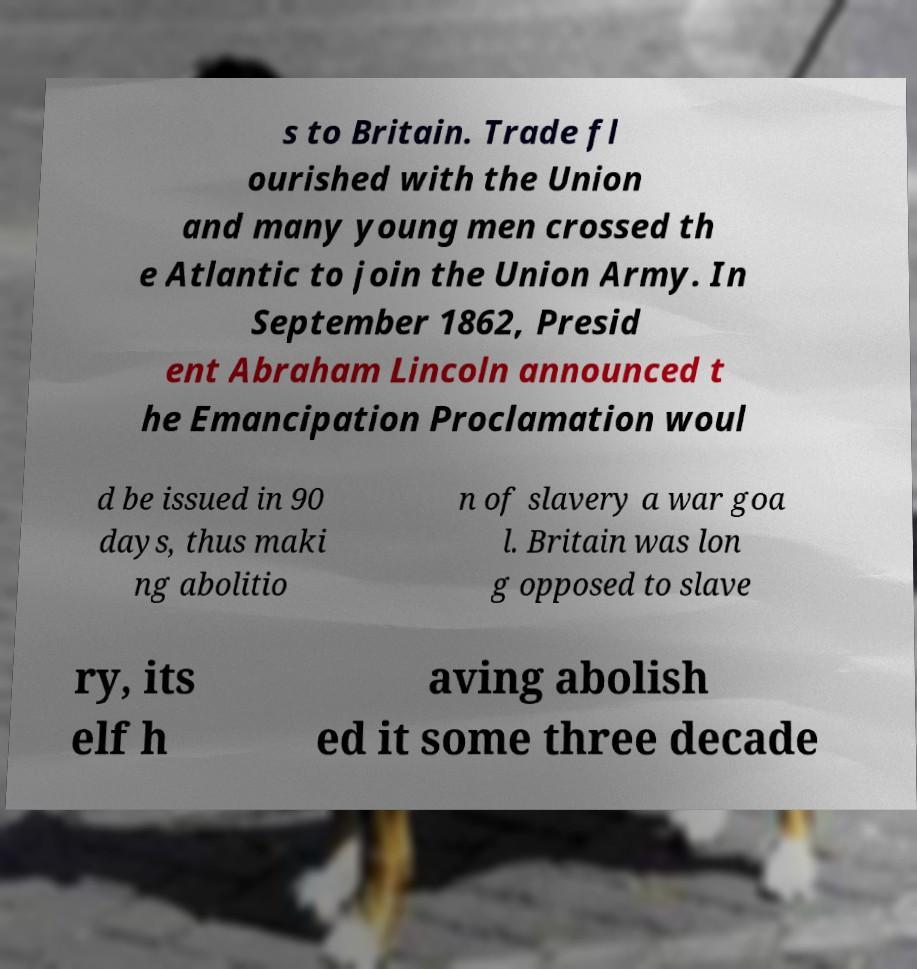I need the written content from this picture converted into text. Can you do that? s to Britain. Trade fl ourished with the Union and many young men crossed th e Atlantic to join the Union Army. In September 1862, Presid ent Abraham Lincoln announced t he Emancipation Proclamation woul d be issued in 90 days, thus maki ng abolitio n of slavery a war goa l. Britain was lon g opposed to slave ry, its elf h aving abolish ed it some three decade 